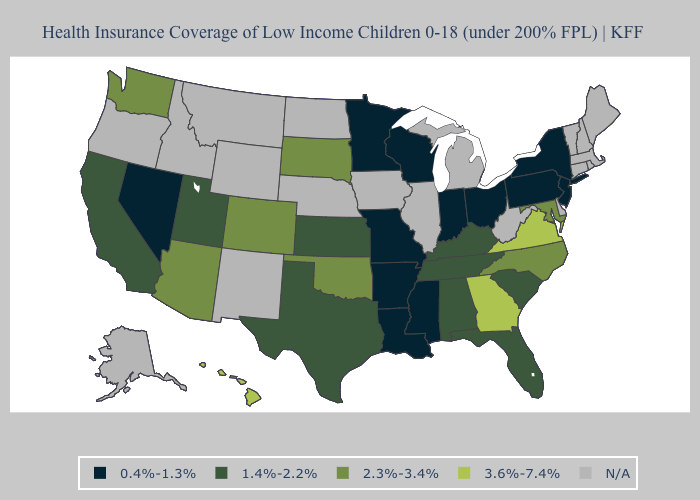Name the states that have a value in the range 2.3%-3.4%?
Write a very short answer. Arizona, Colorado, Maryland, North Carolina, Oklahoma, South Dakota, Washington. Which states have the lowest value in the MidWest?
Answer briefly. Indiana, Minnesota, Missouri, Ohio, Wisconsin. What is the highest value in the MidWest ?
Concise answer only. 2.3%-3.4%. Name the states that have a value in the range 0.4%-1.3%?
Short answer required. Arkansas, Indiana, Louisiana, Minnesota, Mississippi, Missouri, Nevada, New Jersey, New York, Ohio, Pennsylvania, Wisconsin. Which states have the highest value in the USA?
Concise answer only. Georgia, Hawaii, Virginia. Name the states that have a value in the range 2.3%-3.4%?
Concise answer only. Arizona, Colorado, Maryland, North Carolina, Oklahoma, South Dakota, Washington. How many symbols are there in the legend?
Keep it brief. 5. What is the highest value in the USA?
Give a very brief answer. 3.6%-7.4%. What is the highest value in states that border Maryland?
Quick response, please. 3.6%-7.4%. Name the states that have a value in the range N/A?
Quick response, please. Alaska, Connecticut, Delaware, Idaho, Illinois, Iowa, Maine, Massachusetts, Michigan, Montana, Nebraska, New Hampshire, New Mexico, North Dakota, Oregon, Rhode Island, Vermont, West Virginia, Wyoming. Name the states that have a value in the range 0.4%-1.3%?
Be succinct. Arkansas, Indiana, Louisiana, Minnesota, Mississippi, Missouri, Nevada, New Jersey, New York, Ohio, Pennsylvania, Wisconsin. 